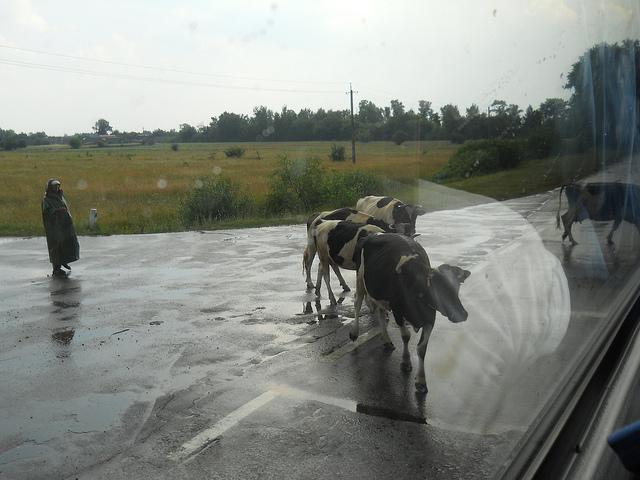What is cast?
Write a very short answer. Reflection. What noise does this animal make?
Keep it brief. Moo. Is the animal a pet?
Keep it brief. No. Are the animals crossing?
Concise answer only. Yes. How many cows are there?
Concise answer only. 4. What are they crossing?
Keep it brief. Road. Has it been raining?
Be succinct. Yes. 